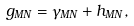Convert formula to latex. <formula><loc_0><loc_0><loc_500><loc_500>g _ { M N } = \gamma _ { M N } + h _ { M N } ,</formula> 